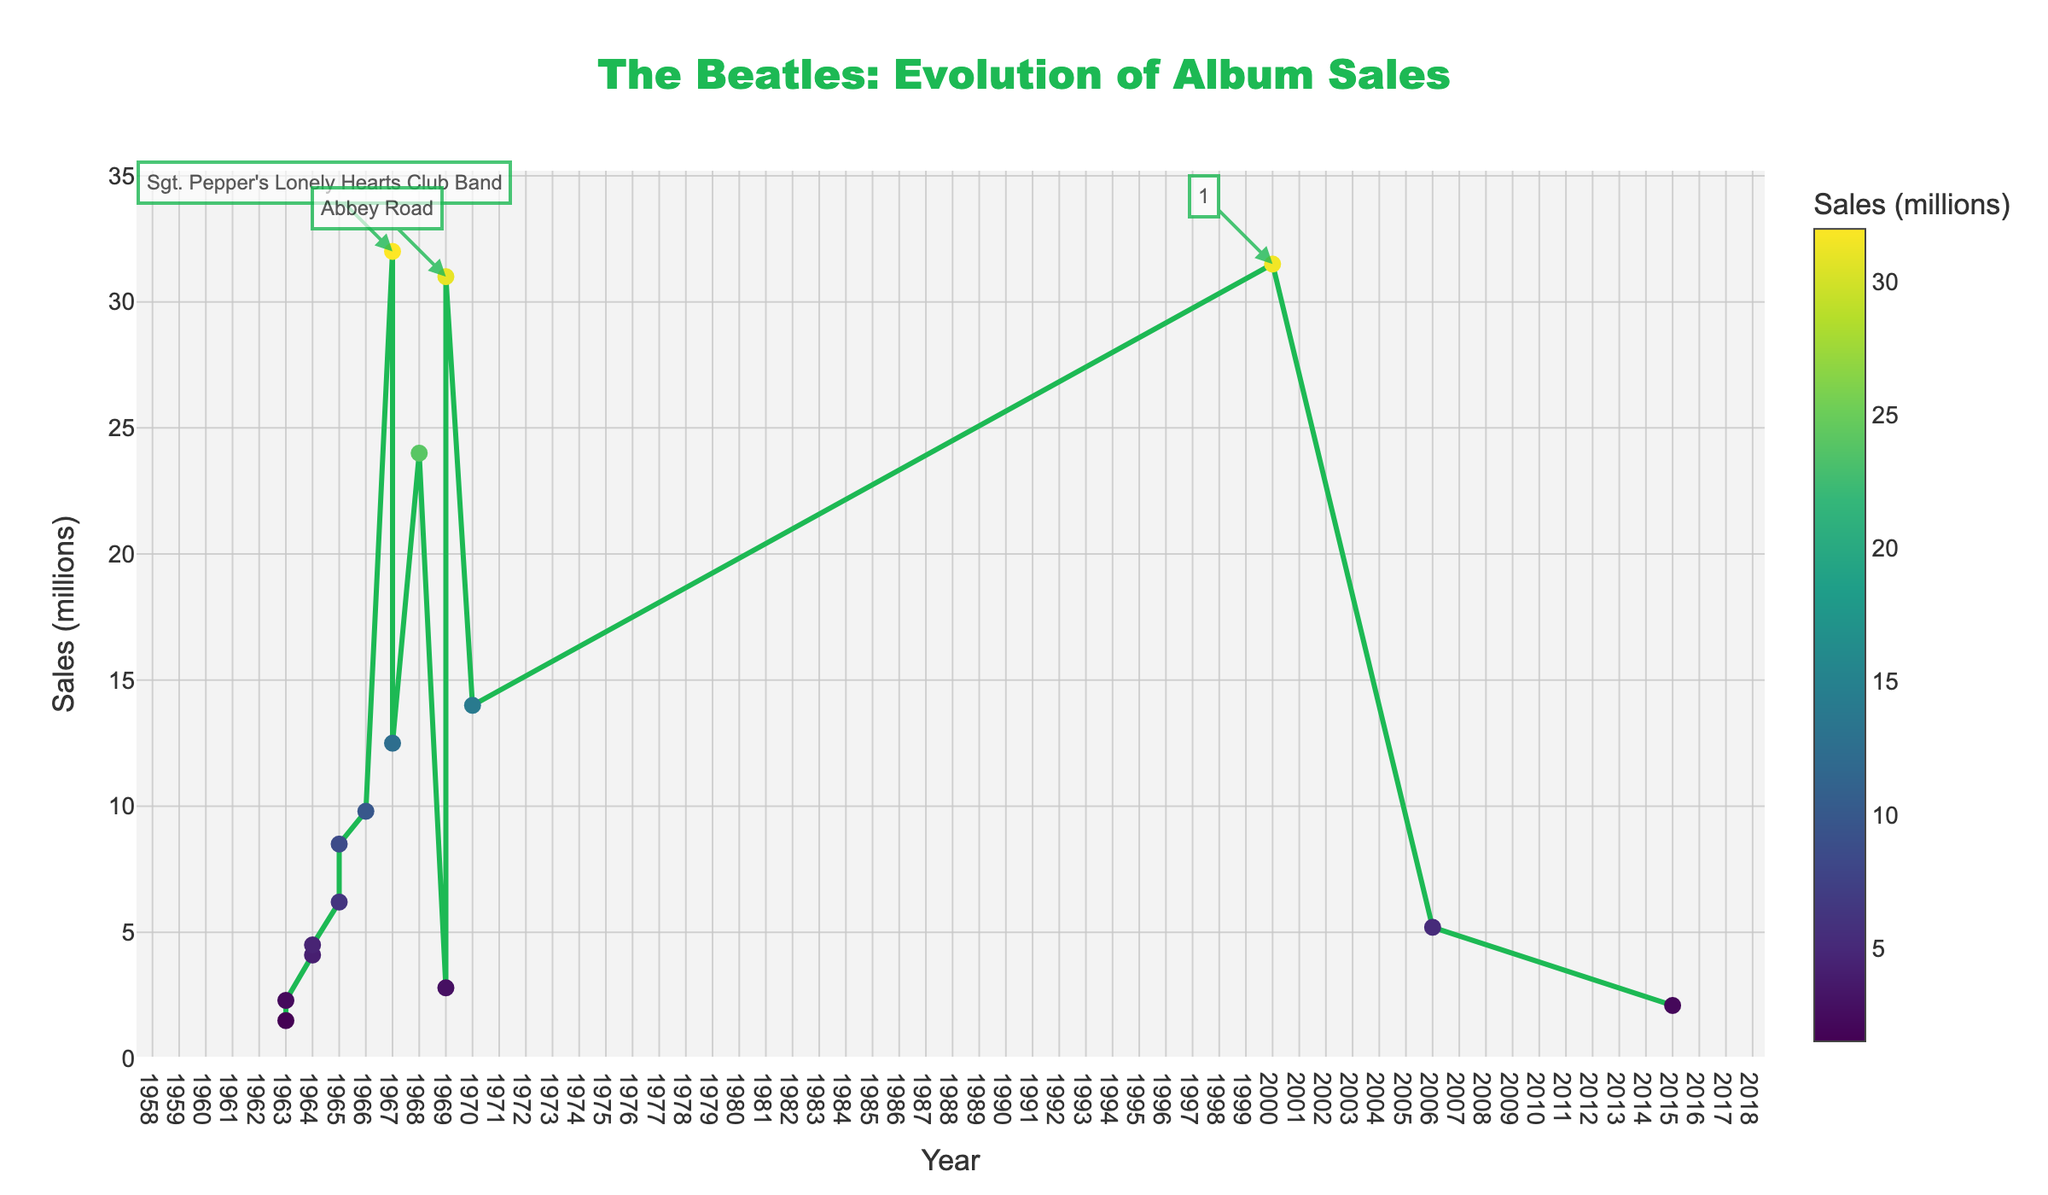Which album has the highest sales? Locate the point with the highest sales on the y-axis and identify the corresponding album. The album with the highest sales is "Sgt. Pepper's Lonely Hearts Club Band".
Answer: "Sgt. Pepper's Lonely Hearts Club Band" What is the total sales of albums released in 1967? Add the sales of "Sgt. Pepper's Lonely Hearts Club Band" and "Magical Mystery Tour" from the year 1967. The total is 32.0 + 12.5 = 44.5 million.
Answer: 44.5 million Which album has higher sales, "Abbey Road" or "The Beatles (White Album)"? Compare the sales of "Abbey Road" and "The Beatles (White Album)". "Abbey Road" has 31.0 million sales, and "The Beatles (White Album)" has 24.0 million sales. "Abbey Road" has higher sales.
Answer: "Abbey Road" What is the average sales of albums released between 1963 and 1965? Identify albums released between 1963 and 1965, sum their sales, and divide by the number of albums. Albums: "Please Please Me", "With The Beatles", "A Hard Day's Night", "Beatles for Sale", "Help!", and "Rubber Soul". Total sales: 1.5 + 2.3 + 4.1 + 4.5 + 6.2 + 8.5 = 27.1 million. There are 6 albums, so the average is 27.1 / 6 ≈ 4.52 million.
Answer: 4.52 million Which year saw the highest number of album releases? Count the number of albums released per year and identify the year with the highest count. Both 1963 and 1969 saw three releases each. However, since only one year is requested "1969" can be chosen for clarity.
Answer: 1969 How much more did "Sgt. Pepper's Lonely Hearts Club Band" sell than "With The Beatles"? Subtract the sales of "With The Beatles" (2.3 million) from "Sgt. Pepper's Lonely Hearts Club Band" (32.0 million). The difference is 32.0 - 2.3 = 29.7 million.
Answer: 29.7 million What is the sales difference between the first and last album in the dataset? Find the sales of the first album "Please Please Me" (1.5 million) and the last album "1+" (2.1 million). Subtract the first album's sales from the last album's sales: 2.1 - 1.5 = 0.6 million.
Answer: 0.6 million Which decade had the highest total sales? Calculate the total sales for each decade and compare them. 1960s: 1.5 + 2.3 + 4.1 + 4.5 + 6.2 + 8.5 + 9.8 + 32.0 + 12.5 + 24.0 + 2.8 + 31.0 + 14.0 = 153.2 million. 2000s: 31.5 + 5.2 + 2.1 = 38.8 million. The 1960s had higher total sales.
Answer: 1960s 